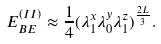<formula> <loc_0><loc_0><loc_500><loc_500>E _ { B E } ^ { ( I I ) } \approx \frac { 1 } { 4 } ( \lambda ^ { x } _ { 1 } \lambda ^ { y } _ { 0 } \lambda ^ { z } _ { 1 } ) ^ { \frac { 2 L } { 3 } } .</formula> 